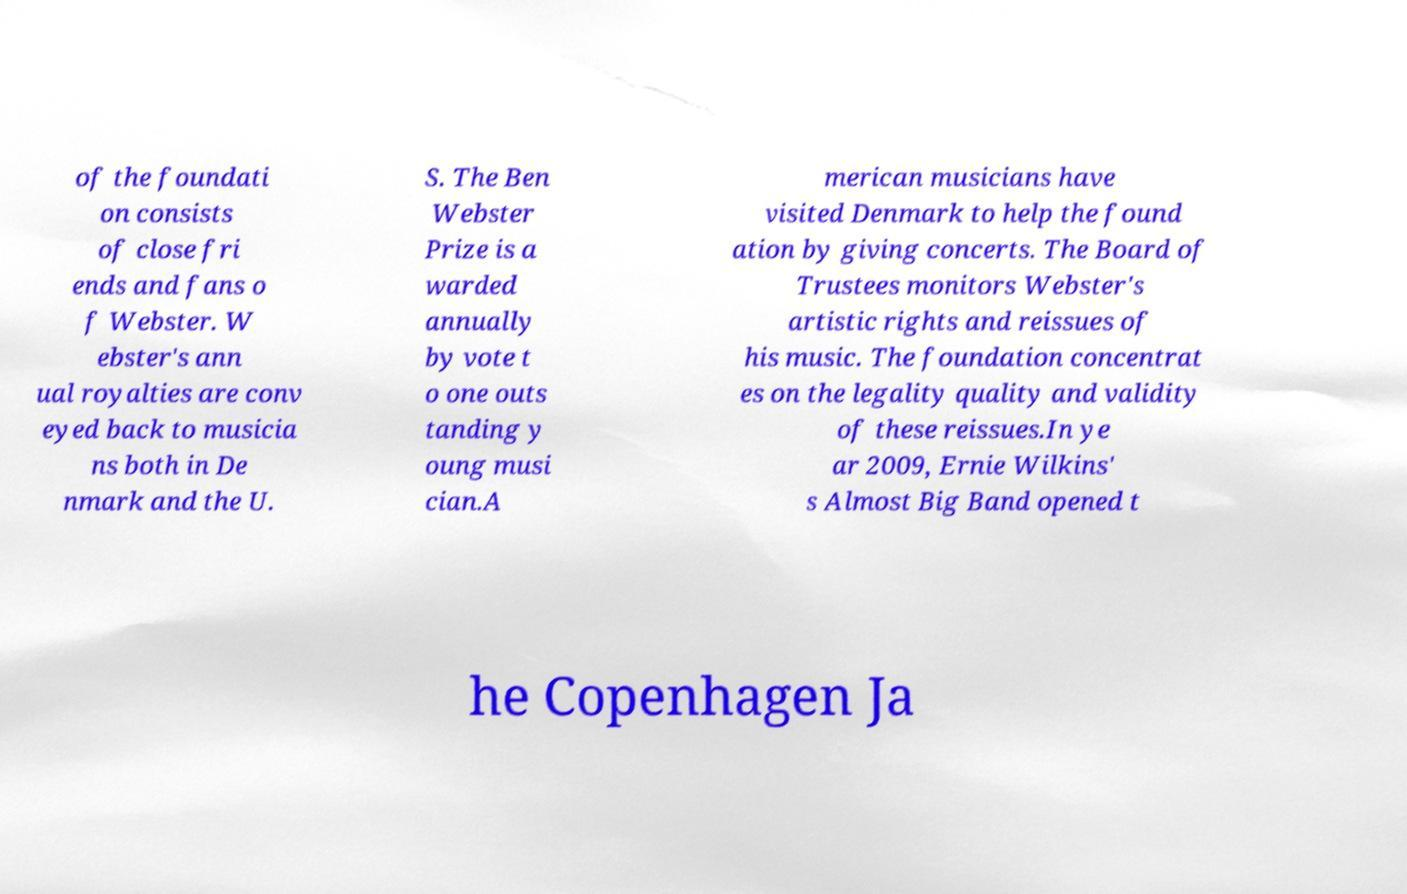There's text embedded in this image that I need extracted. Can you transcribe it verbatim? of the foundati on consists of close fri ends and fans o f Webster. W ebster's ann ual royalties are conv eyed back to musicia ns both in De nmark and the U. S. The Ben Webster Prize is a warded annually by vote t o one outs tanding y oung musi cian.A merican musicians have visited Denmark to help the found ation by giving concerts. The Board of Trustees monitors Webster's artistic rights and reissues of his music. The foundation concentrat es on the legality quality and validity of these reissues.In ye ar 2009, Ernie Wilkins' s Almost Big Band opened t he Copenhagen Ja 